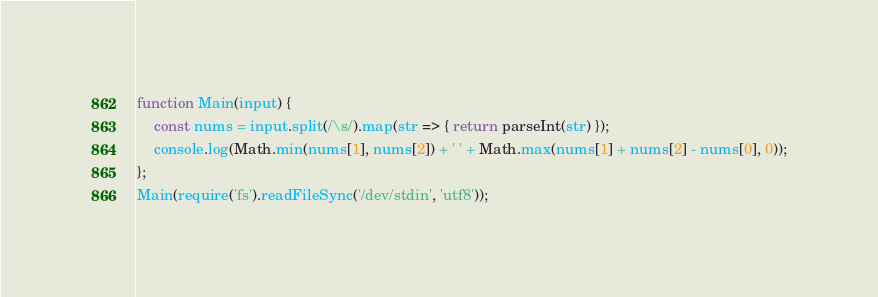<code> <loc_0><loc_0><loc_500><loc_500><_JavaScript_>function Main(input) {
    const nums = input.split(/\s/).map(str => { return parseInt(str) });
    console.log(Math.min(nums[1], nums[2]) + ' ' + Math.max(nums[1] + nums[2] - nums[0], 0));
};
Main(require('fs').readFileSync('/dev/stdin', 'utf8'));</code> 